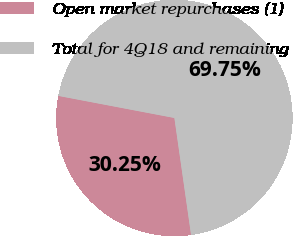Convert chart. <chart><loc_0><loc_0><loc_500><loc_500><pie_chart><fcel>Open market repurchases (1)<fcel>Total for 4Q18 and remaining<nl><fcel>30.25%<fcel>69.75%<nl></chart> 